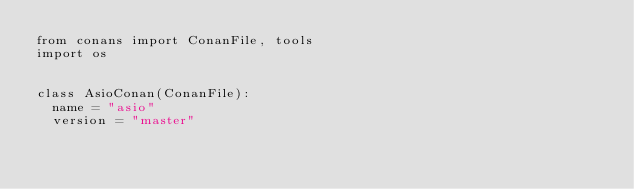Convert code to text. <code><loc_0><loc_0><loc_500><loc_500><_Python_>from conans import ConanFile, tools
import os


class AsioConan(ConanFile):
	name = "asio"
	version = "master"</code> 